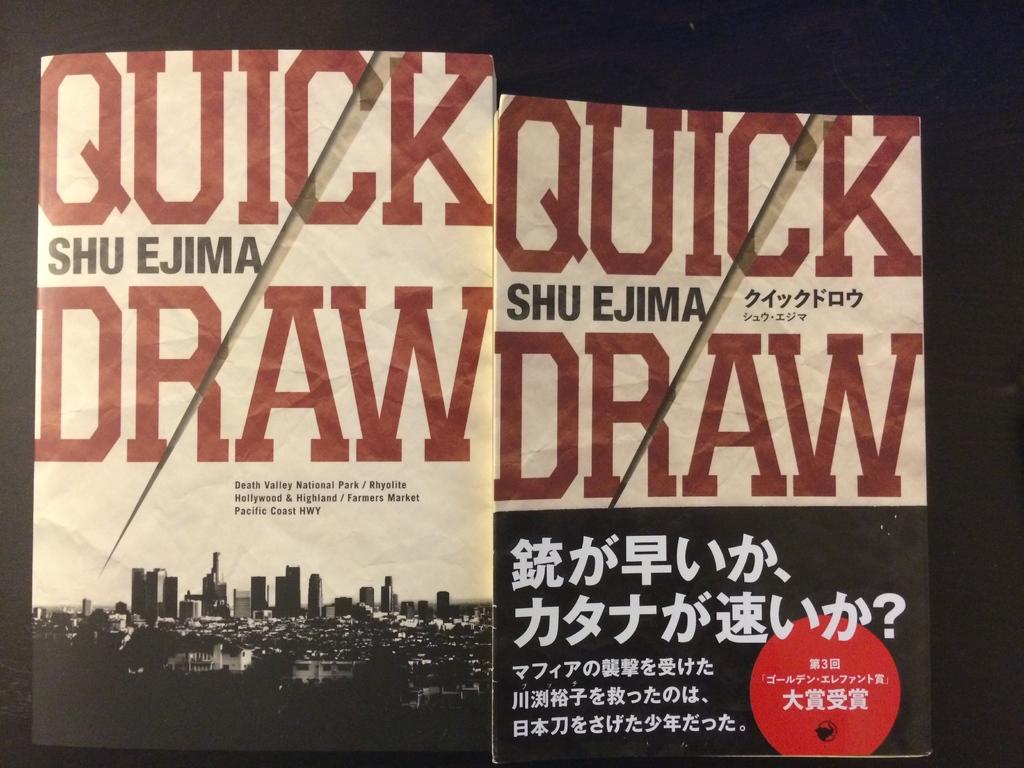What is the title of the book?
Offer a very short reply. Quick draw. What is the authors name written on the book?
Your answer should be compact. Shu ejima. 